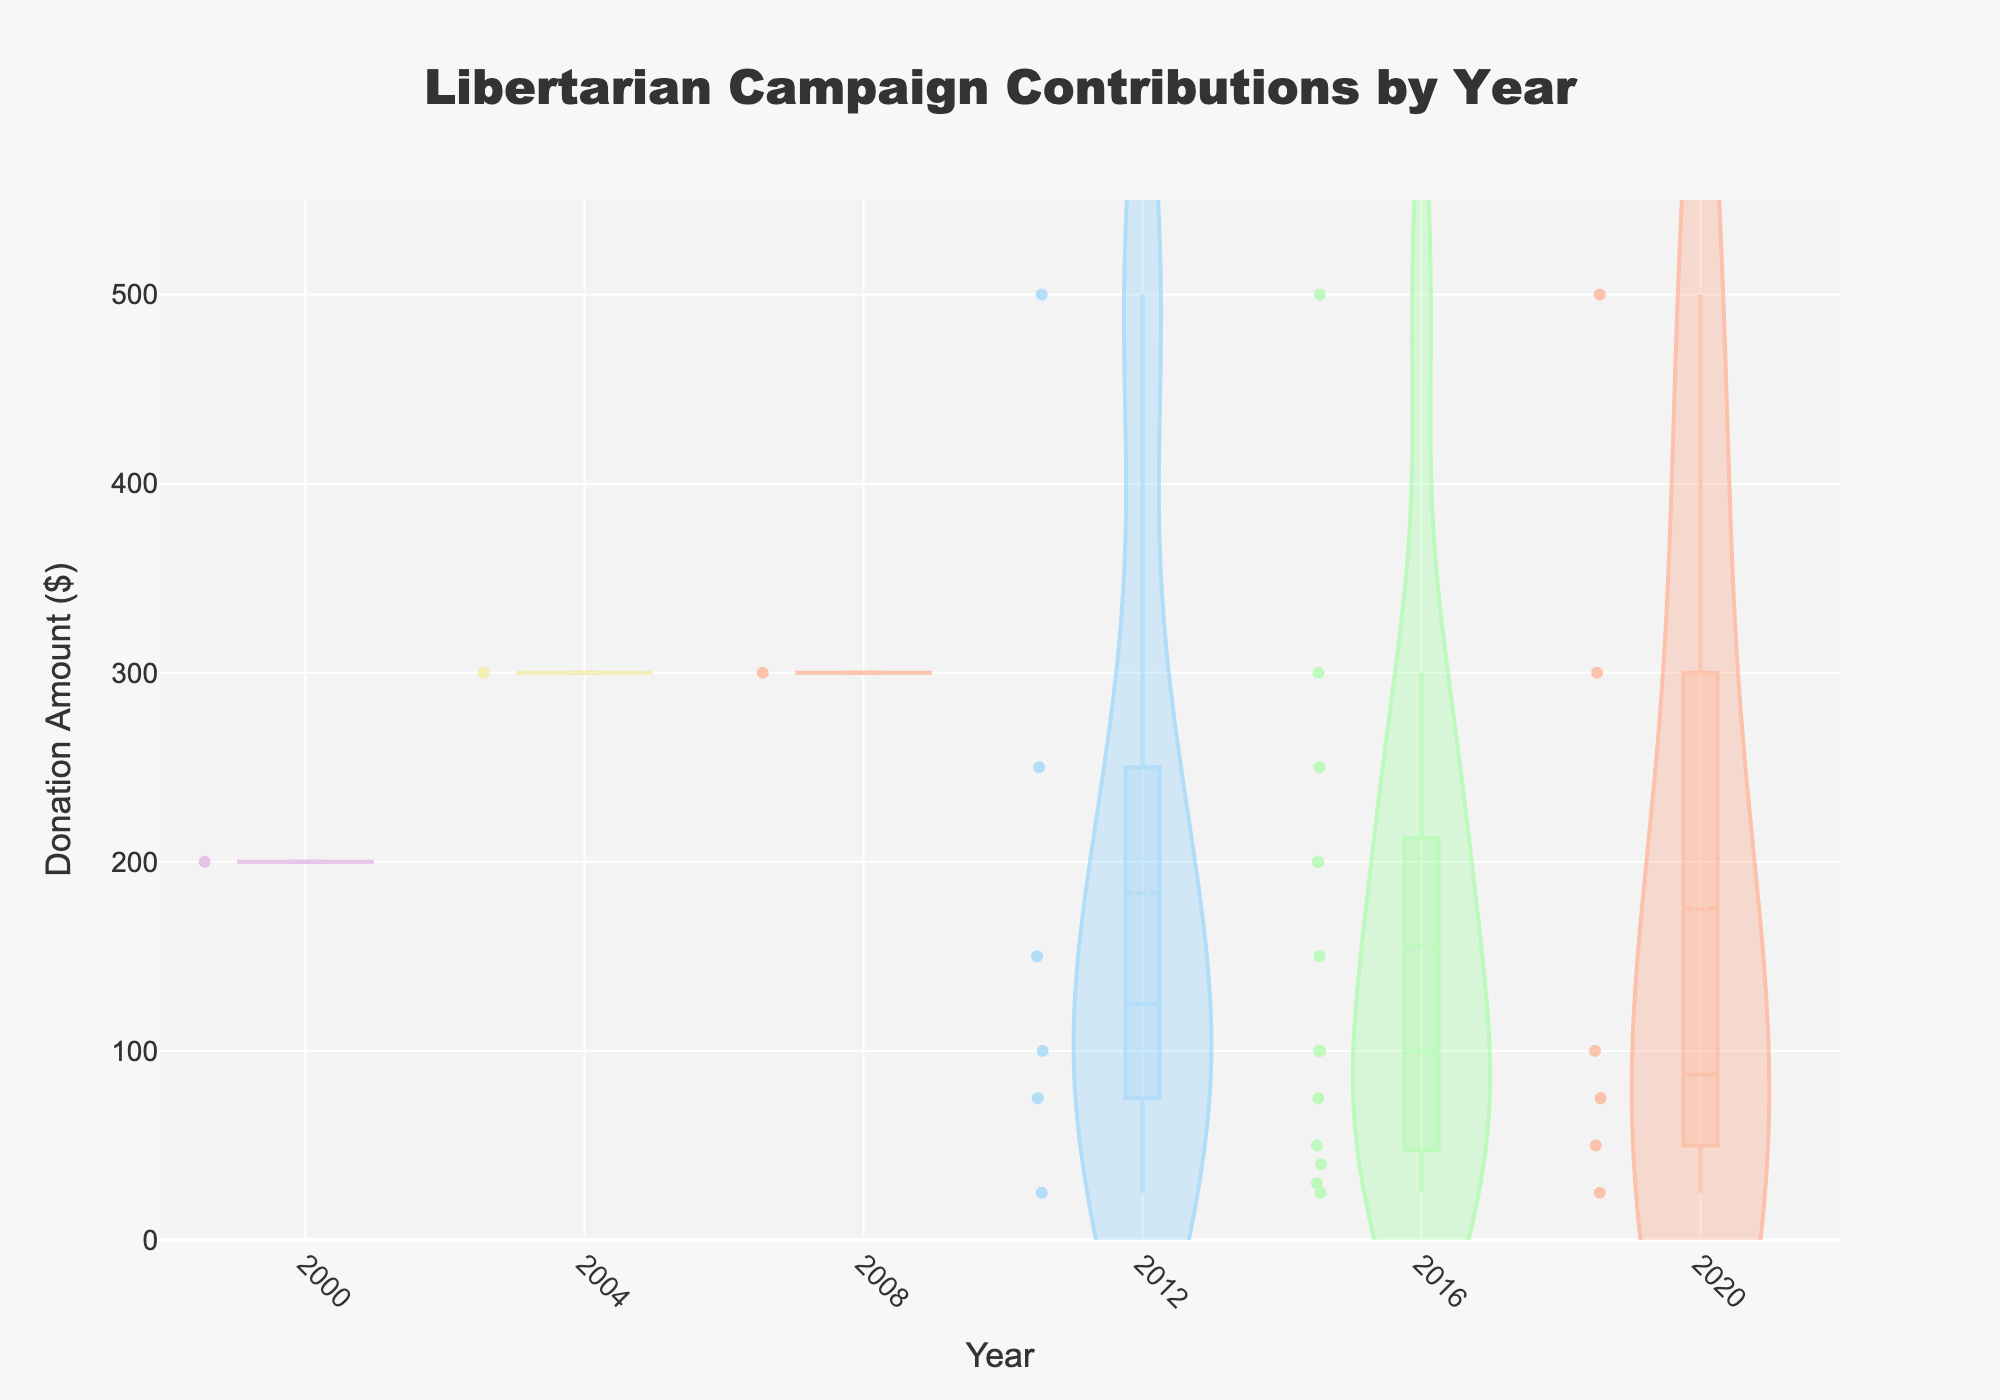What's the title of the figure? The title is clearly displayed at the top of the figure in a larger font size and is centered.
Answer: Libertarian Campaign Contributions by Year What are the highest and lowest donation amounts on the y-axis? By examining the y-axis, the range starts at $0 and goes beyond the maximum observed donation amount. The highest marked value is approximately $550.
Answer: 0, 550 In which year were the highest donation amounts observed? The Violin plot for each year stretches to different levels on the y-axis. By comparing the maximum stretches, 2016 shows the highest outlier point.
Answer: 2016 In the year 2020, what is the median donation amount? The median line is shown within the violin plot for that year (2020) as a white dashed line. By following this line on the y-axis, the median donation is around $100.
Answer: $100 Compare the donation amounts between 2012 and 2020. Which year has a broader distribution of donations? By looking at the spread of the violin plots, 2020 has a broader distribution as the plot stretches further along the y-axis compared to 2012.
Answer: 2020 How many different colors are used to differentiate the years? Observing the color variations across the plots, there are five distinct colors, each representing a specific year.
Answer: 5 Which year shows the smallest range in donation amounts? The range can be identified by the length of the violin plots. The year with the shortest plot length shows the smallest donation range, which is 2000.
Answer: 2000 How does the volume (or count) of donations in 2016 compare to 2020? Thicker sections within the violin plot indicate a higher density of donations. By comparing the thickness, 2020 has a higher density overall compared to 2016.
Answer: 2020 What's the mean donation amount for the year 2016? The mean line is shown within the 2016 violin plot as a white dashed line. By following this line on the y-axis, the mean donation is around $150.
Answer: $150 What is the apparent trend in donation sizes over the years covered in the plots? Observing the violin plots, early years like 2000 and 2004 have smaller ranges and lower max donations, while recent years, especially 2016 and 2020, show broader distributions indicating a growth in donation size.
Answer: Increasing trend in donation sizes 